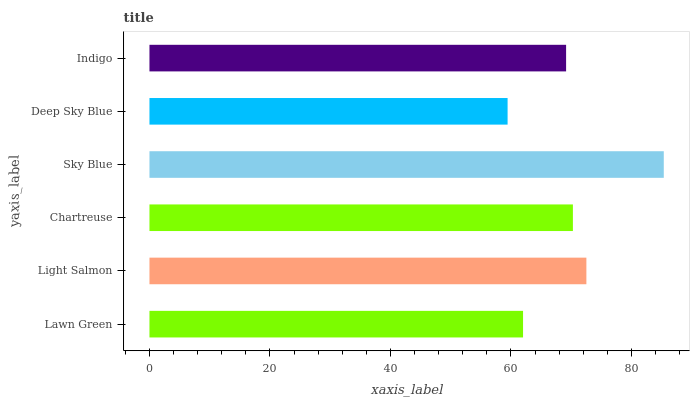Is Deep Sky Blue the minimum?
Answer yes or no. Yes. Is Sky Blue the maximum?
Answer yes or no. Yes. Is Light Salmon the minimum?
Answer yes or no. No. Is Light Salmon the maximum?
Answer yes or no. No. Is Light Salmon greater than Lawn Green?
Answer yes or no. Yes. Is Lawn Green less than Light Salmon?
Answer yes or no. Yes. Is Lawn Green greater than Light Salmon?
Answer yes or no. No. Is Light Salmon less than Lawn Green?
Answer yes or no. No. Is Chartreuse the high median?
Answer yes or no. Yes. Is Indigo the low median?
Answer yes or no. Yes. Is Lawn Green the high median?
Answer yes or no. No. Is Light Salmon the low median?
Answer yes or no. No. 